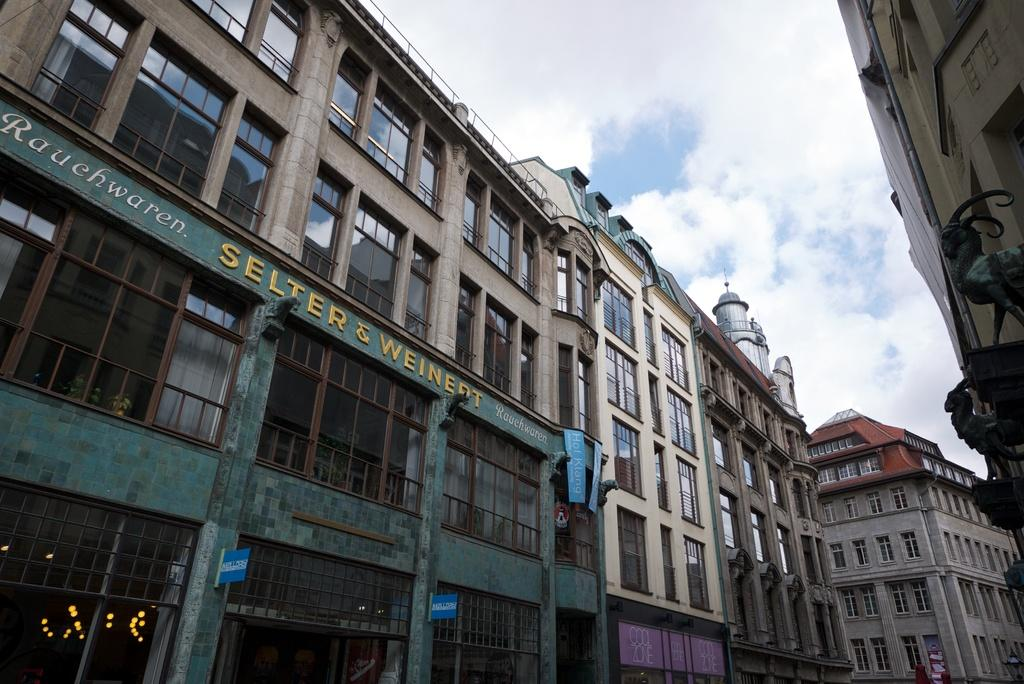What type of structures can be seen in the image? There are buildings in the image. What is visible at the top of the image? The sky is visible at the top of the image. What can be observed in the sky? Clouds are present in the sky. Where is the carpenter working in the image? There is no carpenter present in the image. What type of food is being served in the lunchroom in the image? There is no lunchroom present in the image. 